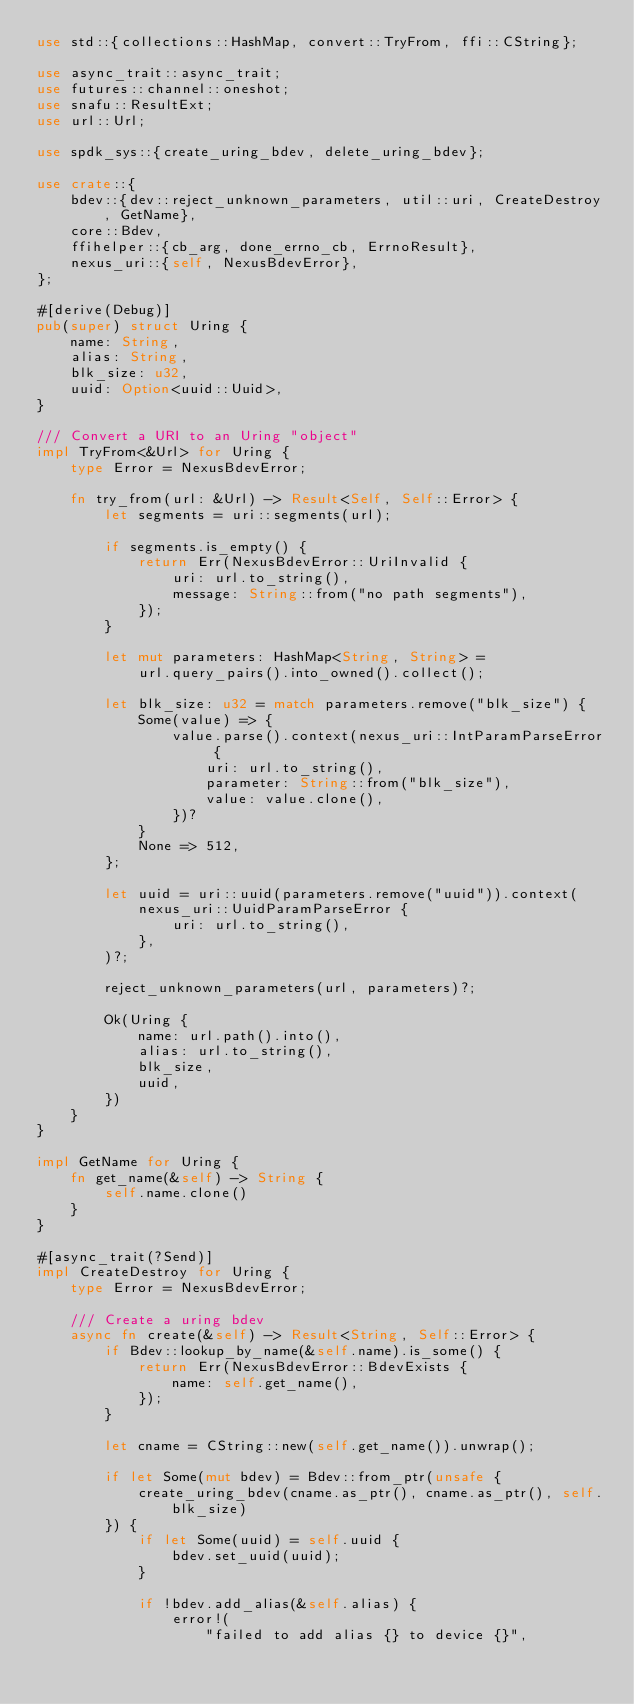<code> <loc_0><loc_0><loc_500><loc_500><_Rust_>use std::{collections::HashMap, convert::TryFrom, ffi::CString};

use async_trait::async_trait;
use futures::channel::oneshot;
use snafu::ResultExt;
use url::Url;

use spdk_sys::{create_uring_bdev, delete_uring_bdev};

use crate::{
    bdev::{dev::reject_unknown_parameters, util::uri, CreateDestroy, GetName},
    core::Bdev,
    ffihelper::{cb_arg, done_errno_cb, ErrnoResult},
    nexus_uri::{self, NexusBdevError},
};

#[derive(Debug)]
pub(super) struct Uring {
    name: String,
    alias: String,
    blk_size: u32,
    uuid: Option<uuid::Uuid>,
}

/// Convert a URI to an Uring "object"
impl TryFrom<&Url> for Uring {
    type Error = NexusBdevError;

    fn try_from(url: &Url) -> Result<Self, Self::Error> {
        let segments = uri::segments(url);

        if segments.is_empty() {
            return Err(NexusBdevError::UriInvalid {
                uri: url.to_string(),
                message: String::from("no path segments"),
            });
        }

        let mut parameters: HashMap<String, String> =
            url.query_pairs().into_owned().collect();

        let blk_size: u32 = match parameters.remove("blk_size") {
            Some(value) => {
                value.parse().context(nexus_uri::IntParamParseError {
                    uri: url.to_string(),
                    parameter: String::from("blk_size"),
                    value: value.clone(),
                })?
            }
            None => 512,
        };

        let uuid = uri::uuid(parameters.remove("uuid")).context(
            nexus_uri::UuidParamParseError {
                uri: url.to_string(),
            },
        )?;

        reject_unknown_parameters(url, parameters)?;

        Ok(Uring {
            name: url.path().into(),
            alias: url.to_string(),
            blk_size,
            uuid,
        })
    }
}

impl GetName for Uring {
    fn get_name(&self) -> String {
        self.name.clone()
    }
}

#[async_trait(?Send)]
impl CreateDestroy for Uring {
    type Error = NexusBdevError;

    /// Create a uring bdev
    async fn create(&self) -> Result<String, Self::Error> {
        if Bdev::lookup_by_name(&self.name).is_some() {
            return Err(NexusBdevError::BdevExists {
                name: self.get_name(),
            });
        }

        let cname = CString::new(self.get_name()).unwrap();

        if let Some(mut bdev) = Bdev::from_ptr(unsafe {
            create_uring_bdev(cname.as_ptr(), cname.as_ptr(), self.blk_size)
        }) {
            if let Some(uuid) = self.uuid {
                bdev.set_uuid(uuid);
            }

            if !bdev.add_alias(&self.alias) {
                error!(
                    "failed to add alias {} to device {}",</code> 